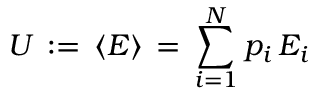<formula> <loc_0><loc_0><loc_500><loc_500>U \, \colon = \, \langle E \rangle \, = \, \sum _ { i = 1 } ^ { N } p _ { i } \, E _ { i }</formula> 